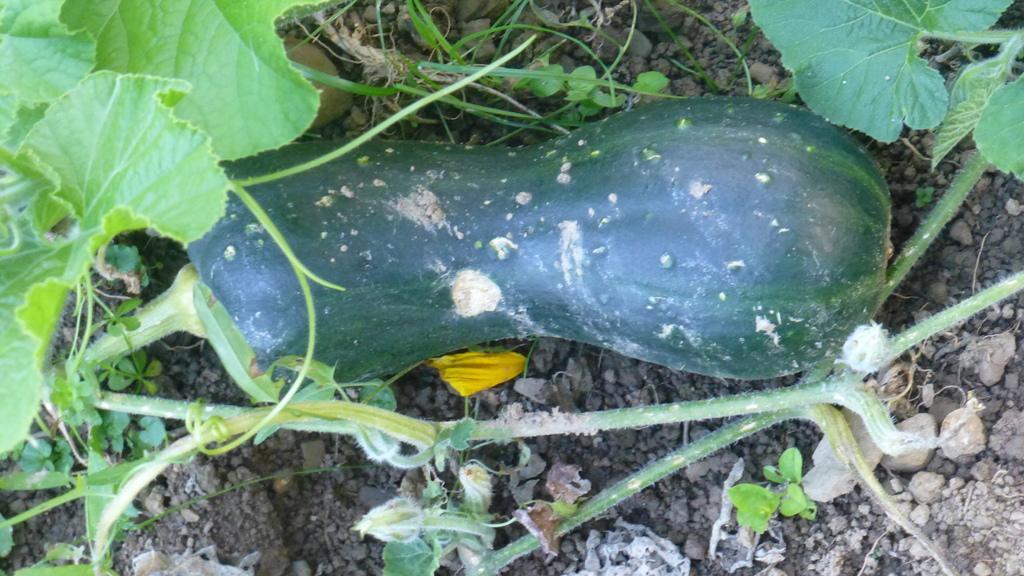How would you summarize this image in a sentence or two? In this image in the center there is one vegetable and also there are some plants, at the bottom there is sand and some small stones. 